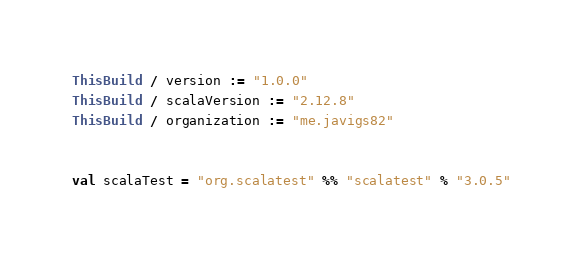Convert code to text. <code><loc_0><loc_0><loc_500><loc_500><_Scala_>ThisBuild / version := "1.0.0"
ThisBuild / scalaVersion := "2.12.8"
ThisBuild / organization := "me.javigs82"


val scalaTest = "org.scalatest" %% "scalatest" % "3.0.5"
</code> 